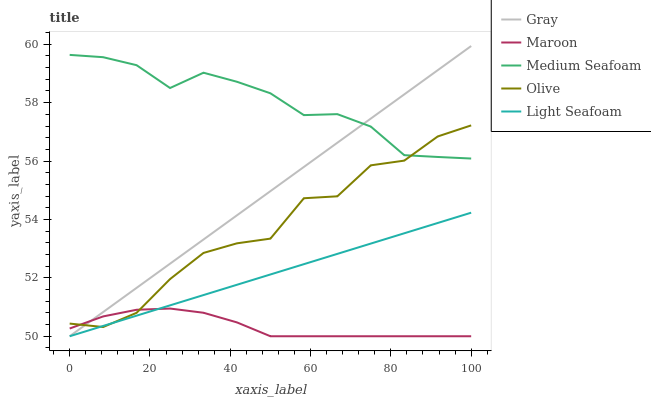Does Maroon have the minimum area under the curve?
Answer yes or no. Yes. Does Medium Seafoam have the maximum area under the curve?
Answer yes or no. Yes. Does Gray have the minimum area under the curve?
Answer yes or no. No. Does Gray have the maximum area under the curve?
Answer yes or no. No. Is Gray the smoothest?
Answer yes or no. Yes. Is Olive the roughest?
Answer yes or no. Yes. Is Light Seafoam the smoothest?
Answer yes or no. No. Is Light Seafoam the roughest?
Answer yes or no. No. Does Gray have the lowest value?
Answer yes or no. Yes. Does Medium Seafoam have the lowest value?
Answer yes or no. No. Does Gray have the highest value?
Answer yes or no. Yes. Does Light Seafoam have the highest value?
Answer yes or no. No. Is Maroon less than Medium Seafoam?
Answer yes or no. Yes. Is Medium Seafoam greater than Maroon?
Answer yes or no. Yes. Does Maroon intersect Gray?
Answer yes or no. Yes. Is Maroon less than Gray?
Answer yes or no. No. Is Maroon greater than Gray?
Answer yes or no. No. Does Maroon intersect Medium Seafoam?
Answer yes or no. No. 